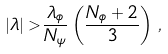<formula> <loc_0><loc_0><loc_500><loc_500>| \lambda | > \frac { \lambda _ { \phi } } { N _ { \psi } } \left ( \frac { N _ { \phi } + 2 } { 3 } \right ) \, ,</formula> 